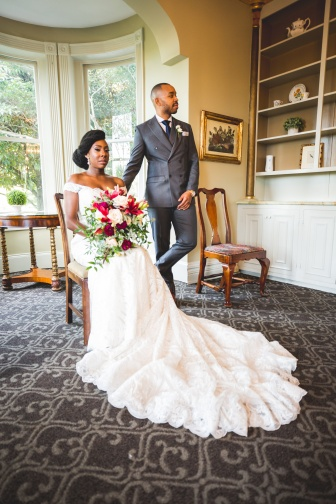Create a scenario where the room itself holds sentimental value to the couple. The room in the image is actually the couple's favorite spot in the home they restored together. When they first bought the house, it was in need of great repair, and they spent countless weekends bringing it back to life. The room, once a disused parlor, became their sanctuary. They sanded the floors, painted the walls, and carefully selected the furniture that now gives it its charm.

This is where they shared countless cups of tea, planned their future, and even where the groom proposed during a quiet, candlelit evening. The bookcase, now filled with memories and tokens of their journey, was the first piece they restored together. On their wedding day, they chose this room for its history, significance, and the love embedded in its walls.  Share a brief, realistic moment that the couple might experience in this room. In this room, the couple might experience a quiet morning together. As the soft light of dawn filters through the window, they sit side by side, sharing a peaceful breakfast. The bride laughs softly at a joke the groom makes, her hand resting on his arm. They discuss their plans for the day, enjoying the tranquility and comfort of their beautifully restored room and the life they are building together. 